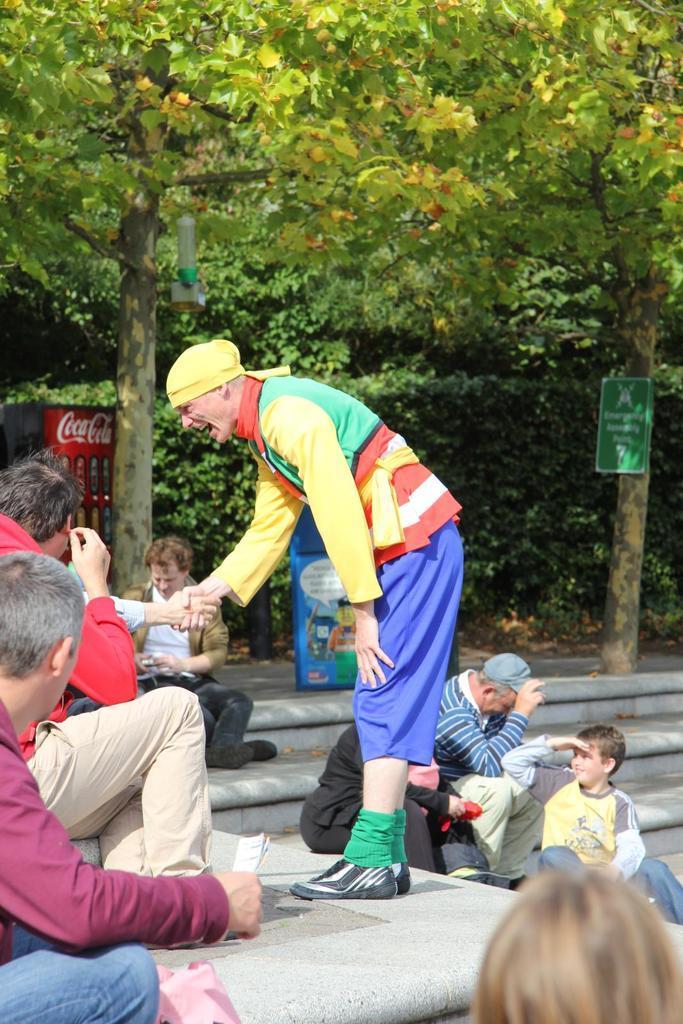Please provide a concise description of this image. This is the man standing and hand shaking with the other person. I can see groups of people sitting on the stairs. This looks like a board, which is attached to the tree trunks. I can see the trees and the bushes. On the left side of the image, that looks like a machine. I think this is the dustbin. 